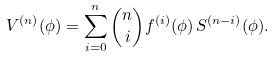<formula> <loc_0><loc_0><loc_500><loc_500>V ^ { ( n ) } ( \phi ) = \sum _ { i = 0 } ^ { n } \binom { n } { i } f ^ { ( i ) } ( \phi ) \, S ^ { ( n - i ) } ( \phi ) .</formula> 